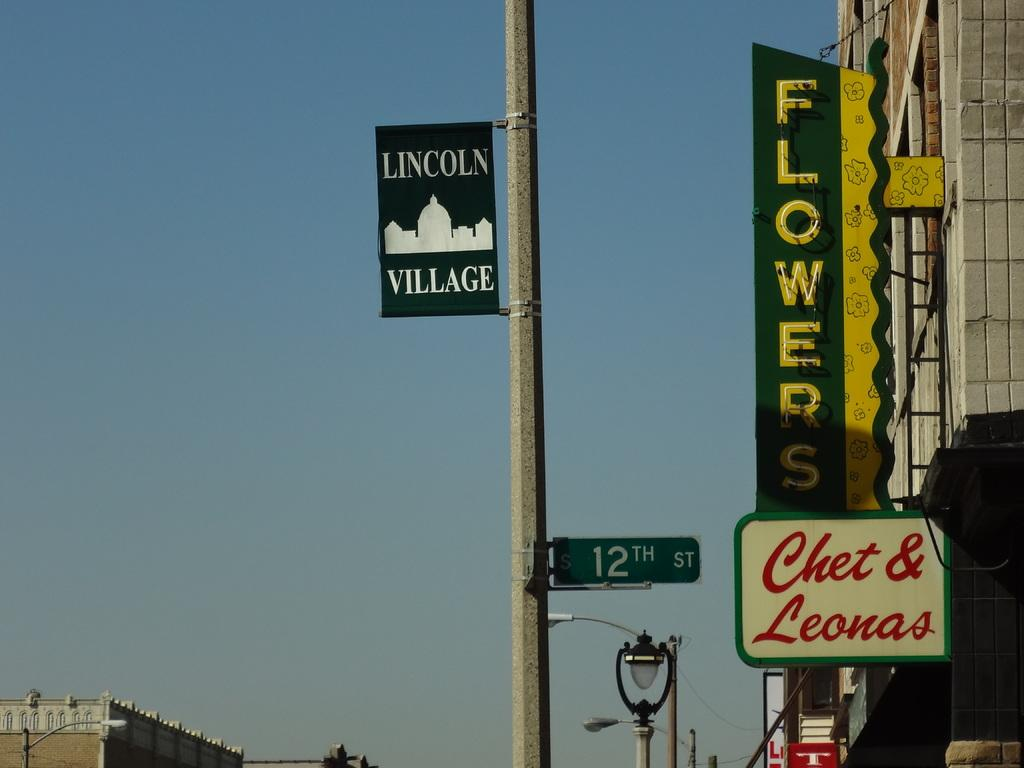Provide a one-sentence caption for the provided image. 12th street sign pole with a "Lincoln Village" sign attached to the pole. 